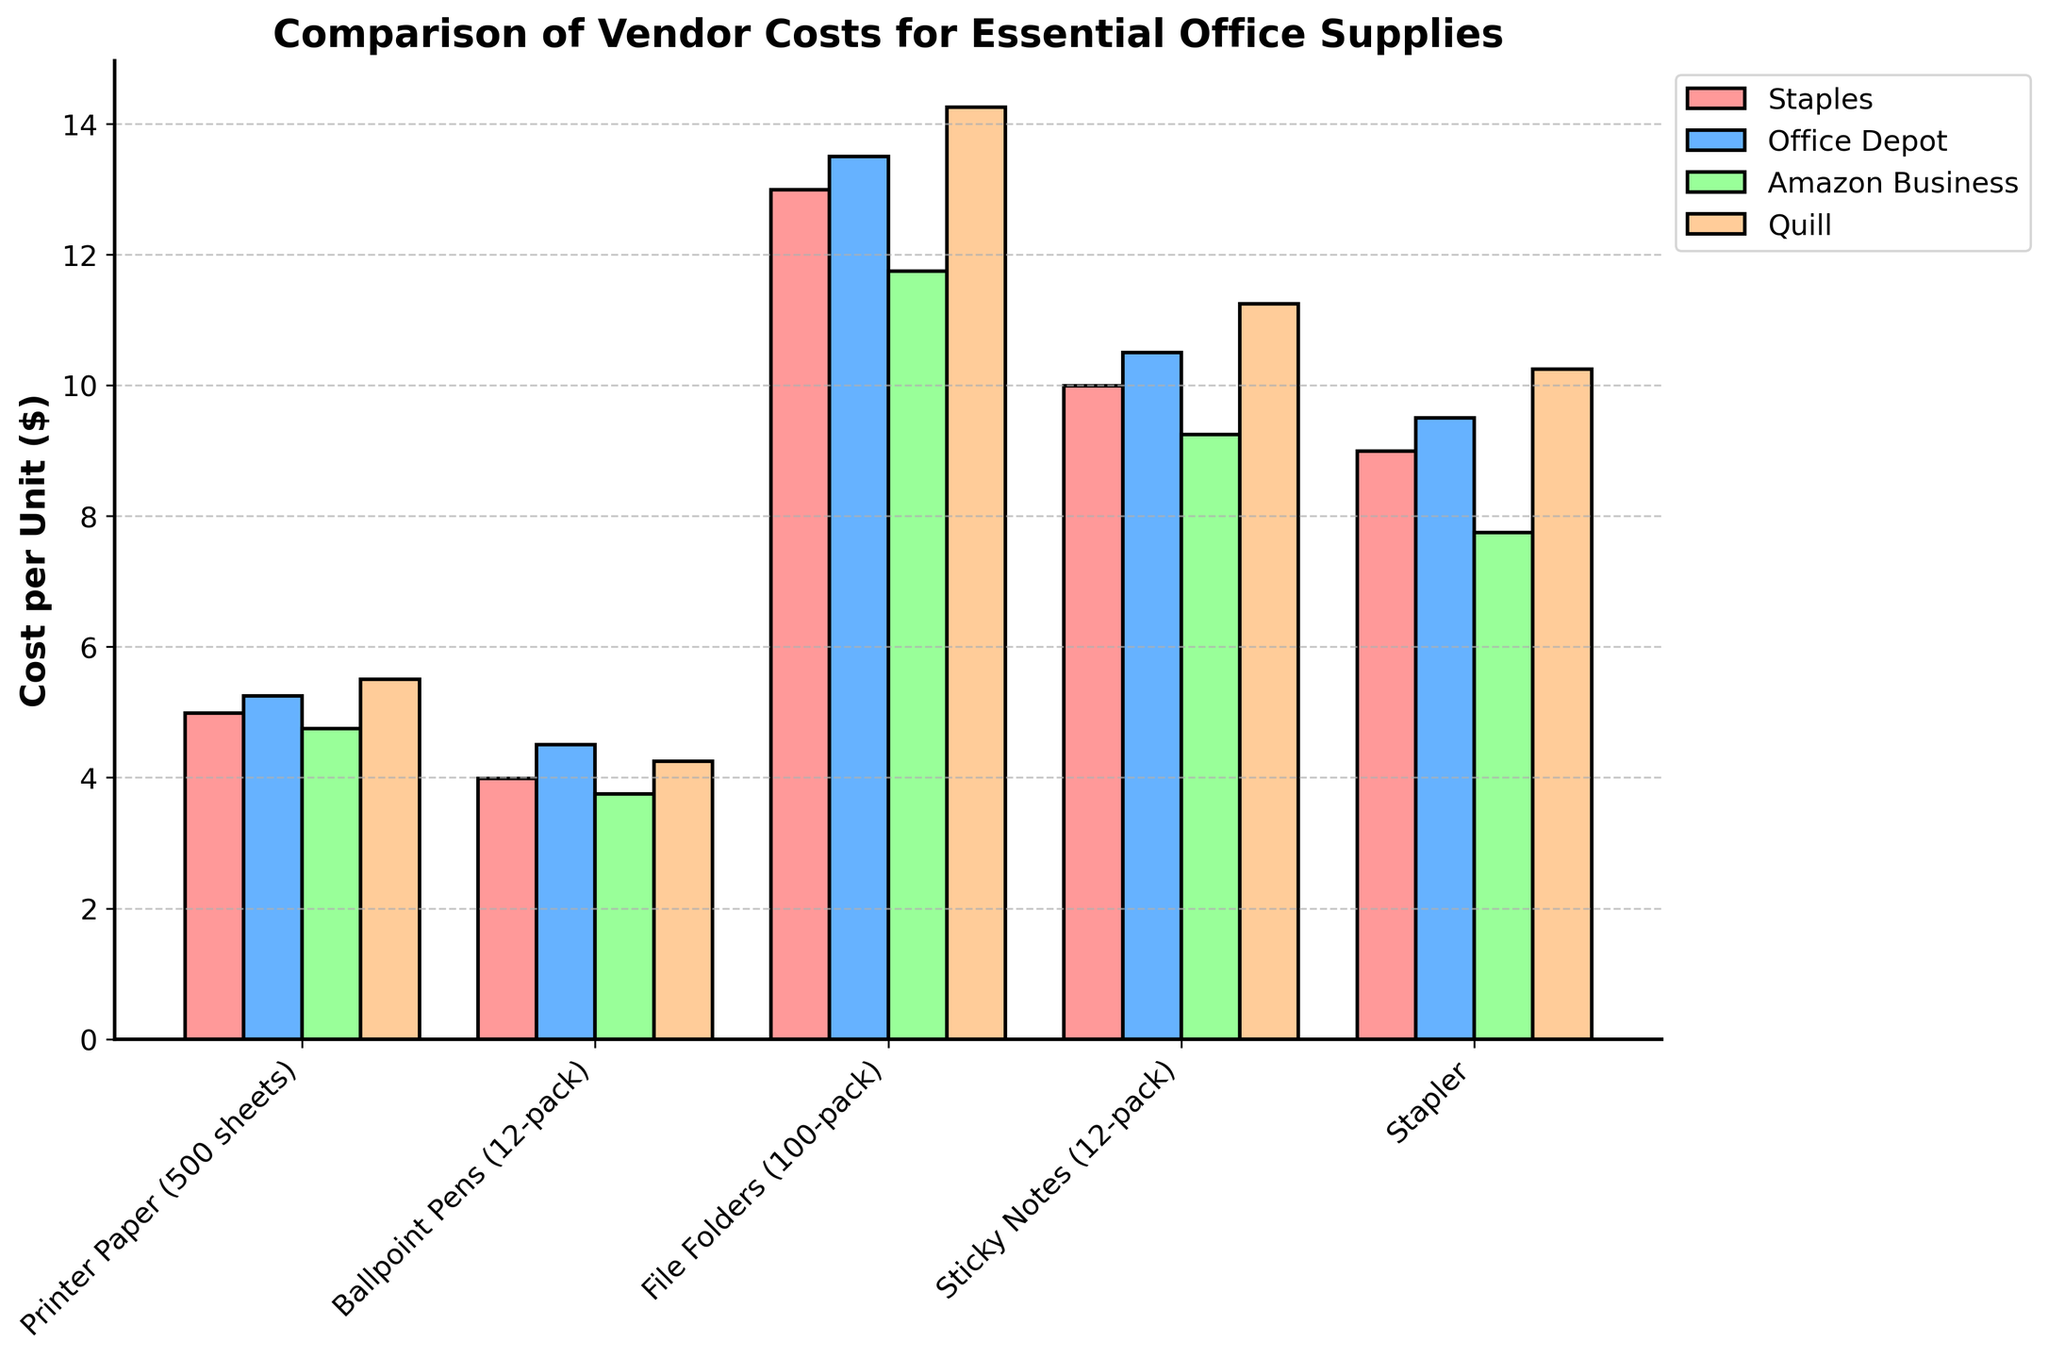Which vendor offers Printer Paper at the lowest cost? Look for the bar representing Printer Paper for each vendor. The shortest bar indicates the lowest cost. Amazon Business offers Printer Paper at 4.75 dollars.
Answer: Amazon Business Which item has the smallest cost difference between the highest and lowest vendor prices? Calculate the cost difference for each item: 
Printer Paper: 5.50 - 4.75 = 0.75 
Ballpoint Pens: 4.50 - 3.75 = 0.75 
File Folders: 14.25 - 11.75 = 2.50 
Sticky Notes: 11.25 - 9.25 = 2.00 
Stapler: 10.25 - 7.75 = 2.50
The smallest difference is 0.75 for Printer Paper and Ballpoint Pens.
Answer: Printer Paper or Ballpoint Pens Which vendor generally has the lowest prices across all items? Compare the height of each vendor's bars. Amazon Business consistently has the lowest bars across most items.
Answer: Amazon Business How much more expensive is the Stapler from Quill compared to Amazon Business? Find the bars for the Stapler from Quill and Amazon Business. 
Cost of Quill Stapler is 10.25 dollars, and Cost of Amazon Business Stapler is 7.75 dollars.
Difference: 10.25 - 7.75 = 2.50 dollars
Answer: 2.50 dollars Which item shows the greatest variation in costs across vendors? Examine the bars for each item and find the item with the highest range between the highest and lowest cost bars.
File Folders have the highest variation: 14.25 - 11.75 = 2.50 dollars.
Answer: File Folders Among the listed vendors, who charges the most for Ballpoint Pens? Look at the bars for Ballpoint Pens for each vendor. The highest bar represents the greatest cost. Office Depot charges the most at 4.50 dollars.
Answer: Office Depot What is the average cost of Sticky Notes across all vendors? Add up the cost of Sticky Notes from each vendor and divide by the number of vendors. 
(9.99 + 10.50 + 9.25 + 11.25)/4 = 10.25 dollars
Answer: 10.25 dollars Are there any items priced exactly the same by any two vendors? Compare the bar heights for each item across vendors to check for identical heights. There are no items with identical prices by any two vendors.
Answer: No If we buy one of each item from Staples, what is the total cost? Sum up the costs for each item from Staples:
4.99 + 3.99 + 12.99 + 9.99 + 8.99 = 40.95 dollars
Answer: 40.95 dollars 